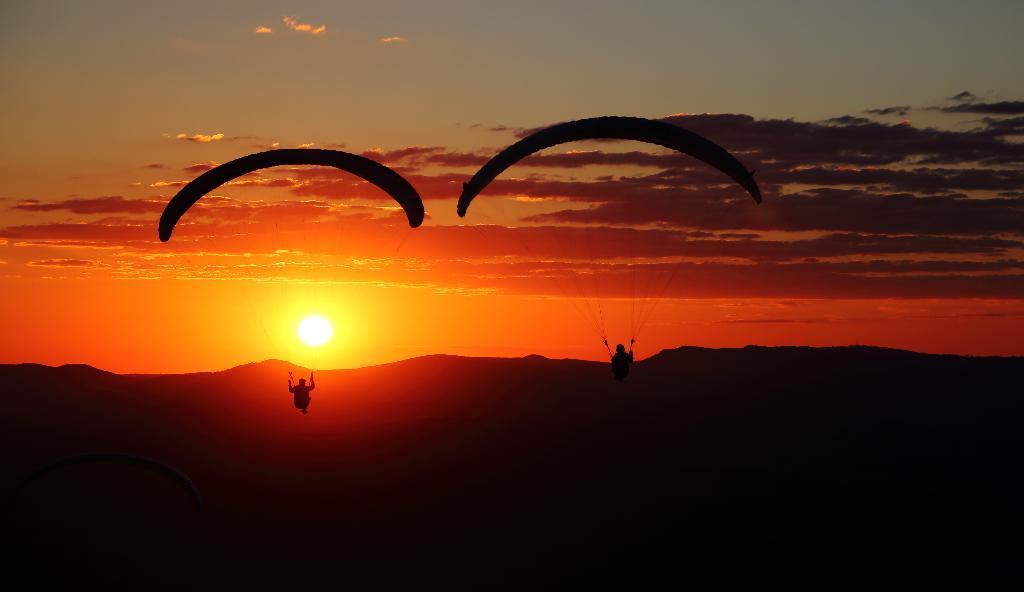Can you describe this image briefly? In this image I can see two people with the parachutes and these people are in the air. In the background I can see the mountains, sun, clouds and the sky. 